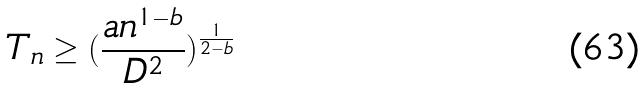Convert formula to latex. <formula><loc_0><loc_0><loc_500><loc_500>T _ { n } \geq ( \frac { a n ^ { 1 - b } } { D ^ { 2 } } ) ^ { \frac { 1 } { 2 - b } }</formula> 